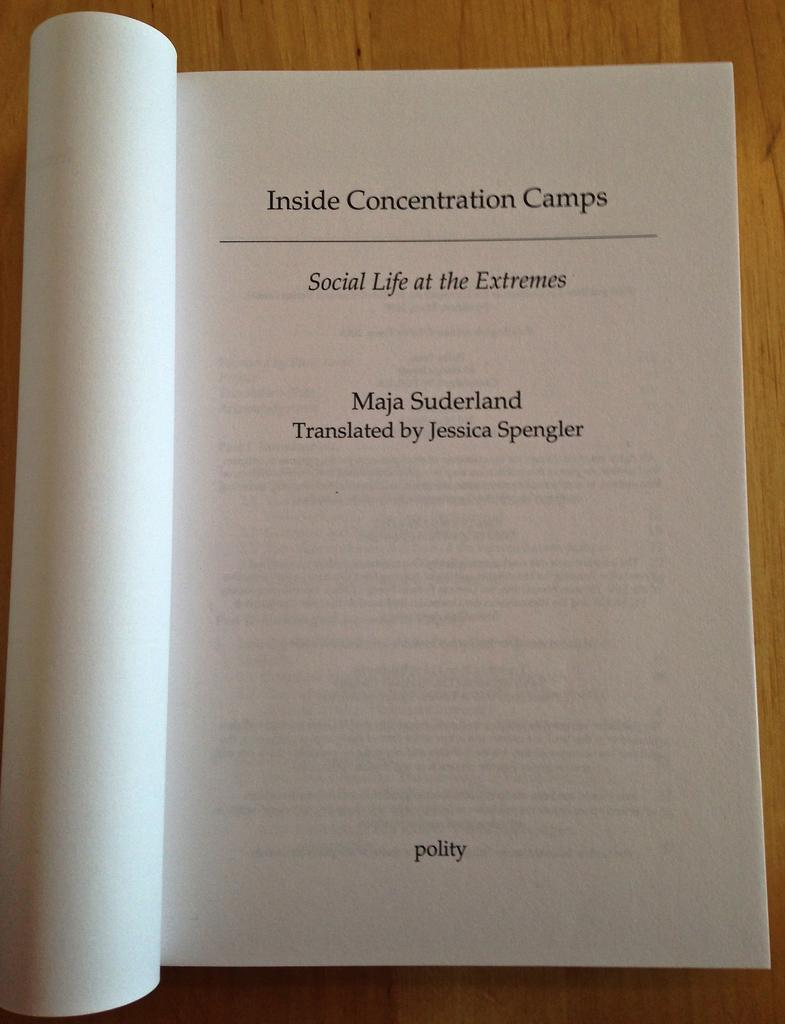<image>
Provide a brief description of the given image. Maja Suderland's writings about concentration camps has been translated by Jessica Spengler. 